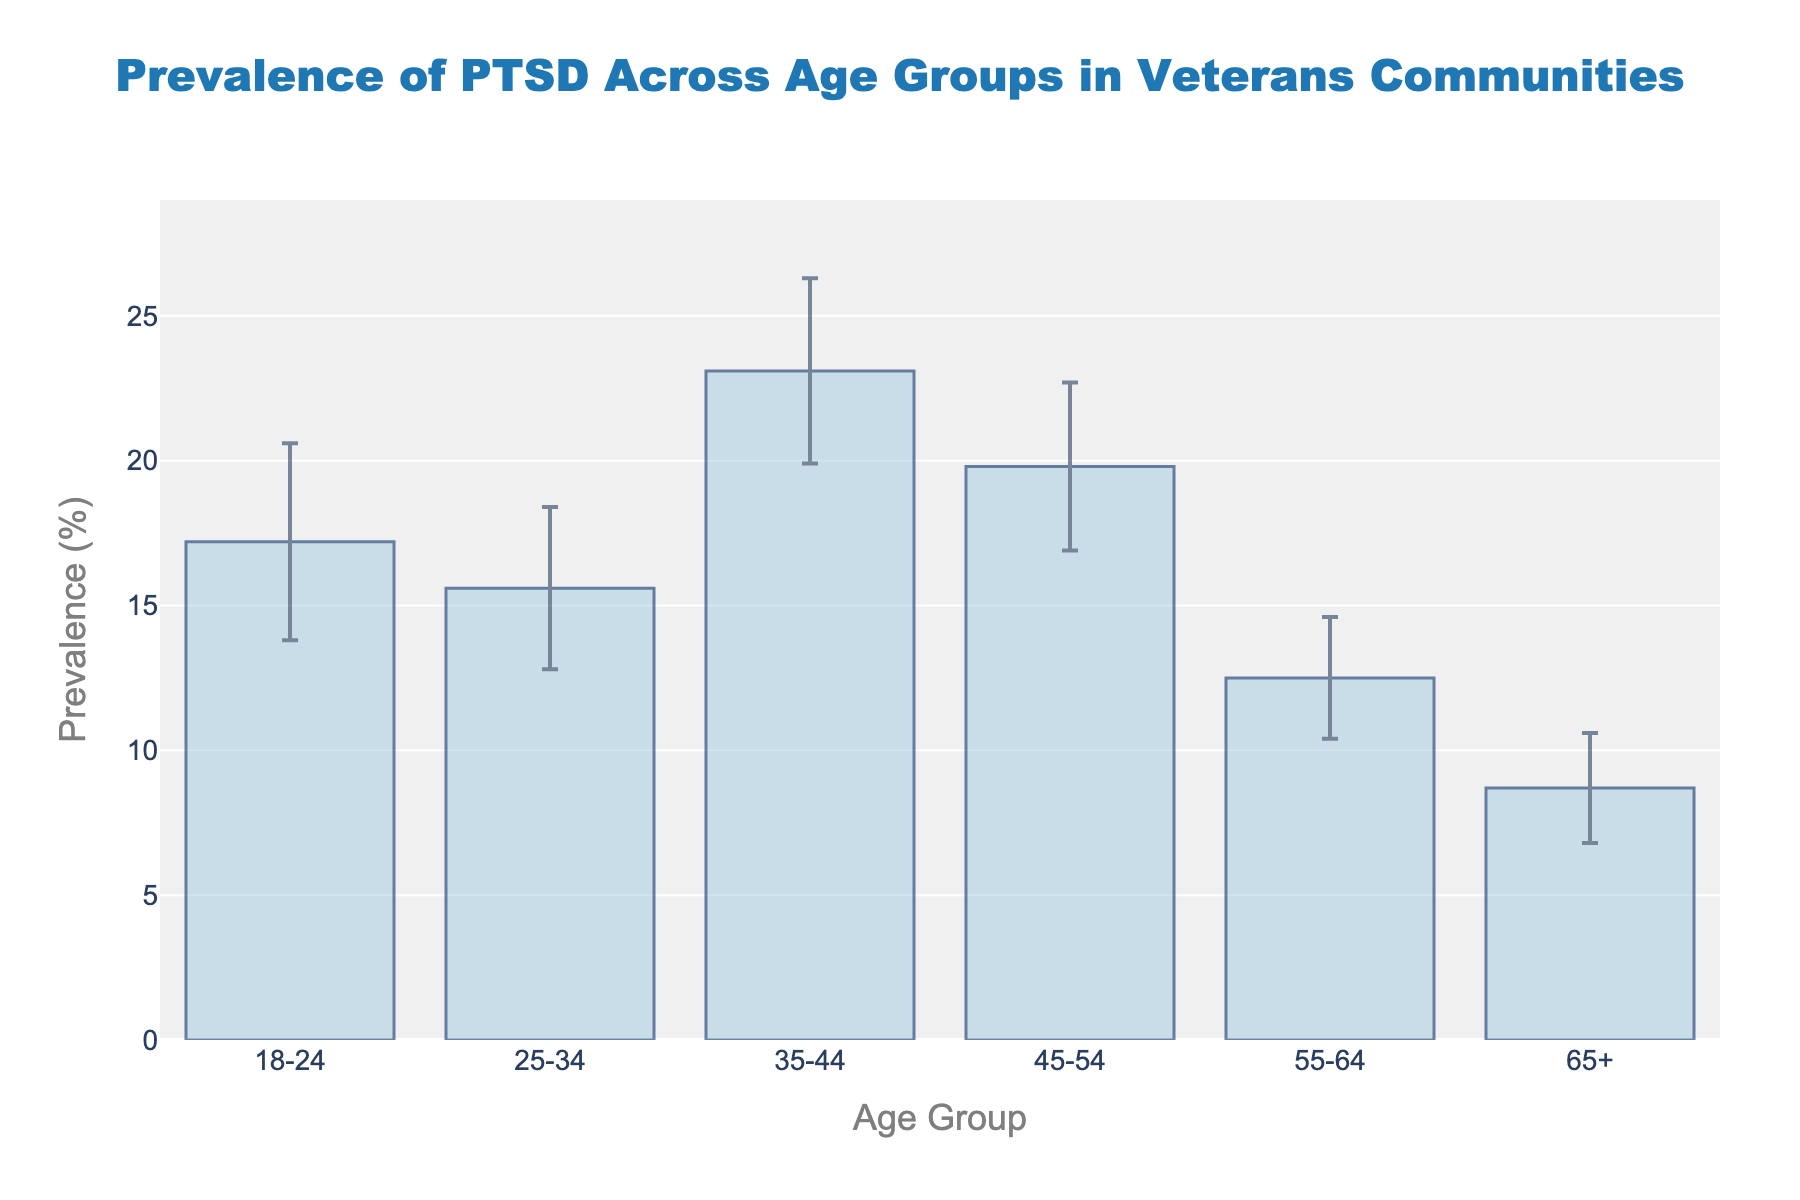What is the title of the figure? The title of a figure is usually found at the top and provides a brief description of what the figure represents. In this case, it reads "Prevalence of PTSD Across Age Groups in Veterans Communities".
Answer: Prevalence of PTSD Across Age Groups in Veterans Communities What is the x-axis label in the figure? The x-axis label provides information about the categories or groups represented on the horizontal axis. Here, it indicates the age groups of veterans.
Answer: Age Group What is the y-axis label in the figure? The y-axis label describes what is being measured or compared on the vertical axis. In this figure, it is the "Prevalence (%)" of PTSD.
Answer: Prevalence (%) Which age group has the highest prevalence of PTSD? To determine this, look at the bar heights representing the PTSD prevalence percentages for each age group. The tallest bar corresponds to the 35-44 age group with a prevalence of 23.1%.
Answer: 35-44 Which age group has the lowest prevalence of PTSD, and what is the percentage? Identify the age group with the shortest bar. The 65+ age group has the lowest prevalence at 8.7%.
Answer: 65+, 8.7% Compare the prevalence of PTSD in the 25-34 and 55-64 age groups. Which is higher, and by how much? The 25-34 age group has a prevalence of 15.6%, while the 55-64 age group has 12.5%. Subtract the latter from the former to find the difference: 15.6% - 12.5% = 3.1%.
Answer: 25-34, 3.1% What is the range of the y-axis in the figure? The range of the y-axis is established between the minimum and maximum values displayed. Here, it extends from 0% to slightly above the highest prevalence value of 23.1%, which suggests the range is 0% to 30%.
Answer: 0% to 30% What is the margin of error for the 45-54 age group? The error bar for this group indicates the margin of error. It is detailed as 2.9%.
Answer: 2.9% Which age group has the largest margin of error, and what is the value? Examining the error bars, the age group 18-24 has the largest margin of error at 3.4%.
Answer: 18-24, 3.4% How much greater is the margin of error for the 18-24 age group compared to the 65+ age group? The 18-24 age group has a margin of error of 3.4%, and the 65+ group has 1.9%. Subtract the latter from the former: 3.4% - 1.9% = 1.5%.
Answer: 1.5% 